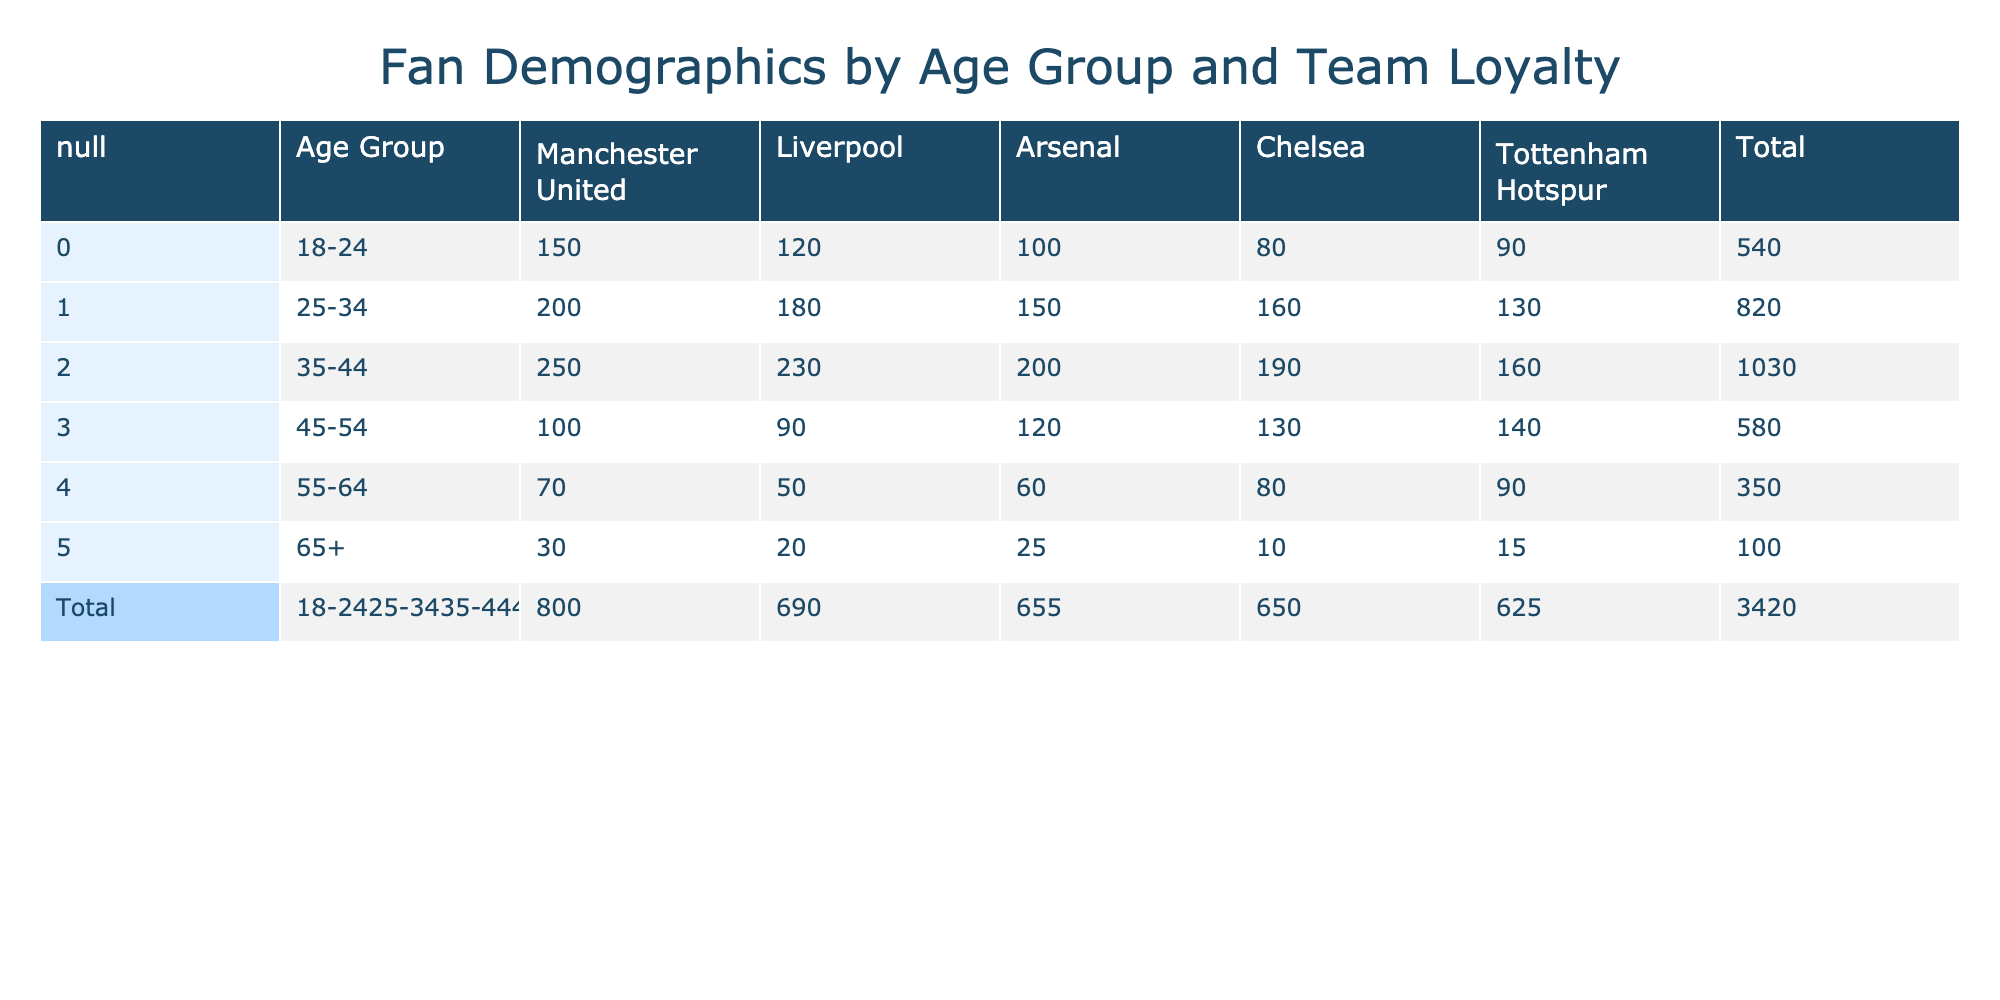What is the total number of fans aged 18-24 who support Manchester United? From the table, the number of fans aged 18-24 who support Manchester United is explicitly listed as 150.
Answer: 150 What is the number of fans supporting Arsenal in the age group 45-54? Looking directly at the table, the number of fans aged 45-54 who support Arsenal is given as 120.
Answer: 120 How many Manchester United fans are there in the age group 35-44 compared to the age group 55-64? The number of fans aged 35-44 supporting Manchester United is 250, while for the age group 55-64, it is 70. The difference is 250 - 70 = 180.
Answer: 180 Which team has the least amount of support from fans aged 65 and above? According to the table, Tottenham Hotspur has 15 fans aged 65 and older, which is lower than Liverpool (20), Arsenal (25), Chelsea (10), and Manchester United (30). Hence, Chelsea has the least support in this age group.
Answer: Chelsea What is the total number of fans for Liverpool across all age groups? To find the total number of fans for Liverpool, we sum up the fans from all age groups: 120 + 180 + 230 + 90 + 50 + 20 = 690.
Answer: 690 Is there a higher number of fans aged 55-64 for Arsenal than for Liverpool? The number of fans aged 55-64 supporting Arsenal is 60, while the number for Liverpool is 50. Therefore, Arsenal has more fans in this age group.
Answer: Yes What percentage of the total fans aged 25-34 support Chelsea? The total for the age group 25-34 is the sum: 200 + 180 + 150 + 160 + 130 = 920. The number of Chelsea fans in this age group is 160. The percentage is (160/920) * 100 = 17.39%.
Answer: 17.39% How many more fans aged 45-54 support Tottenham Hotspur compared to those aged 18-24? For Tottenham Hotspur, the fans aged 45-54 are 140, while for 18-24, there are 90 fans. The difference is 140 - 90 = 50 more fans in the 45-54 age group.
Answer: 50 What is the average number of fans across all age groups for Chelsea? To calculate the average for Chelsea, we sum the number: 80 + 160 + 190 + 130 + 80 + 10 = 650, then divide by the number of age groups, which is 6. So, average = 650 / 6 = 108.33.
Answer: 108.33 